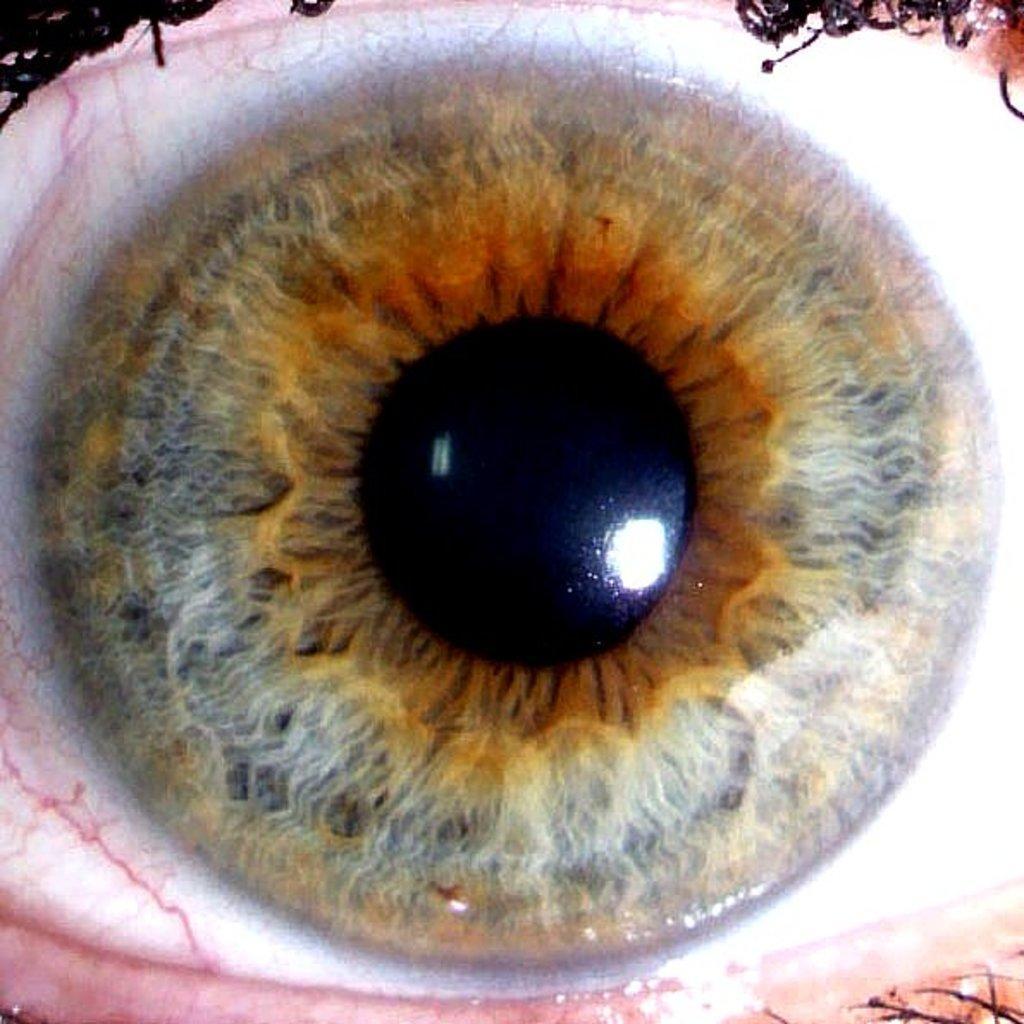Please provide a concise description of this image. In the image there is an eye of the human. 